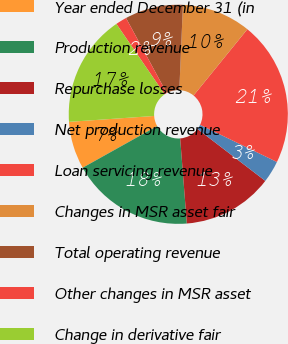Convert chart to OTSL. <chart><loc_0><loc_0><loc_500><loc_500><pie_chart><fcel>Year ended December 31 (in<fcel>Production revenue<fcel>Repurchase losses<fcel>Net production revenue<fcel>Loan servicing revenue<fcel>Changes in MSR asset fair<fcel>Total operating revenue<fcel>Other changes in MSR asset<fcel>Change in derivative fair<nl><fcel>7.01%<fcel>18.13%<fcel>13.36%<fcel>3.23%<fcel>21.31%<fcel>10.18%<fcel>8.59%<fcel>1.64%<fcel>16.54%<nl></chart> 